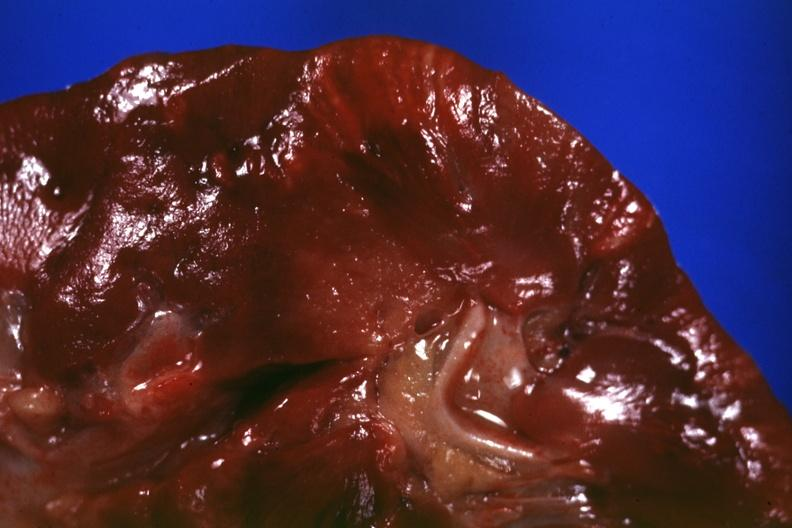does this image show cut surface?
Answer the question using a single word or phrase. Yes 